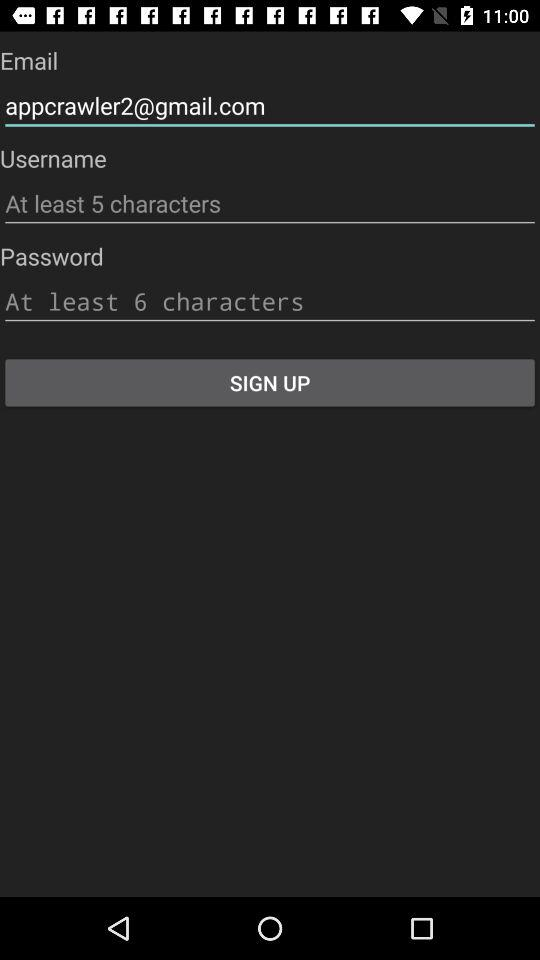What is the least number of characters that should be used for the password? There should be at least 6 characters. 